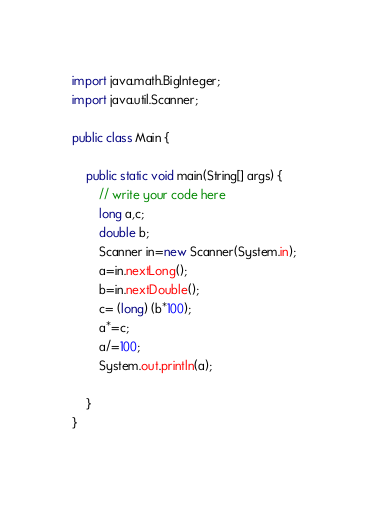<code> <loc_0><loc_0><loc_500><loc_500><_Java_>import java.math.BigInteger;
import java.util.Scanner;

public class Main {

    public static void main(String[] args) {
        // write your code here
        long a,c;
        double b;
        Scanner in=new Scanner(System.in);
        a=in.nextLong();
        b=in.nextDouble();
        c= (long) (b*100);
        a*=c;
        a/=100;
        System.out.println(a);

    }
}
</code> 